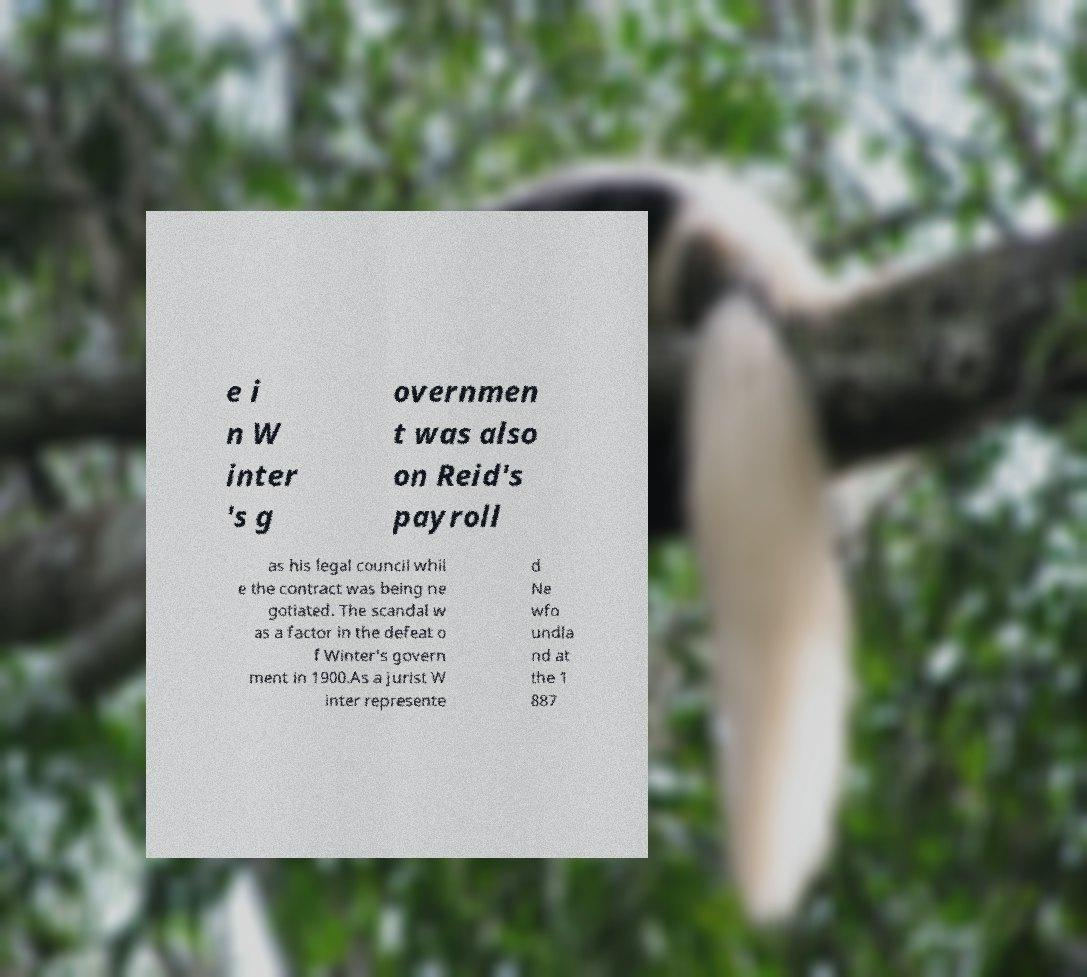For documentation purposes, I need the text within this image transcribed. Could you provide that? e i n W inter 's g overnmen t was also on Reid's payroll as his legal council whil e the contract was being ne gotiated. The scandal w as a factor in the defeat o f Winter's govern ment in 1900.As a jurist W inter represente d Ne wfo undla nd at the 1 887 